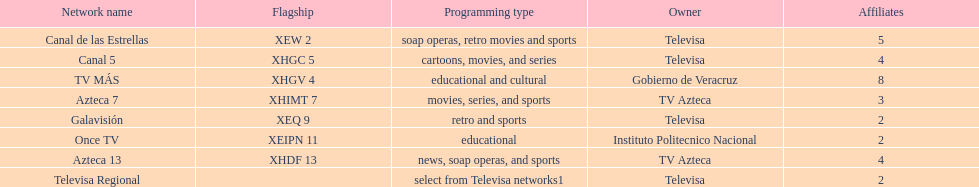Which owner has the most networks? Televisa. 